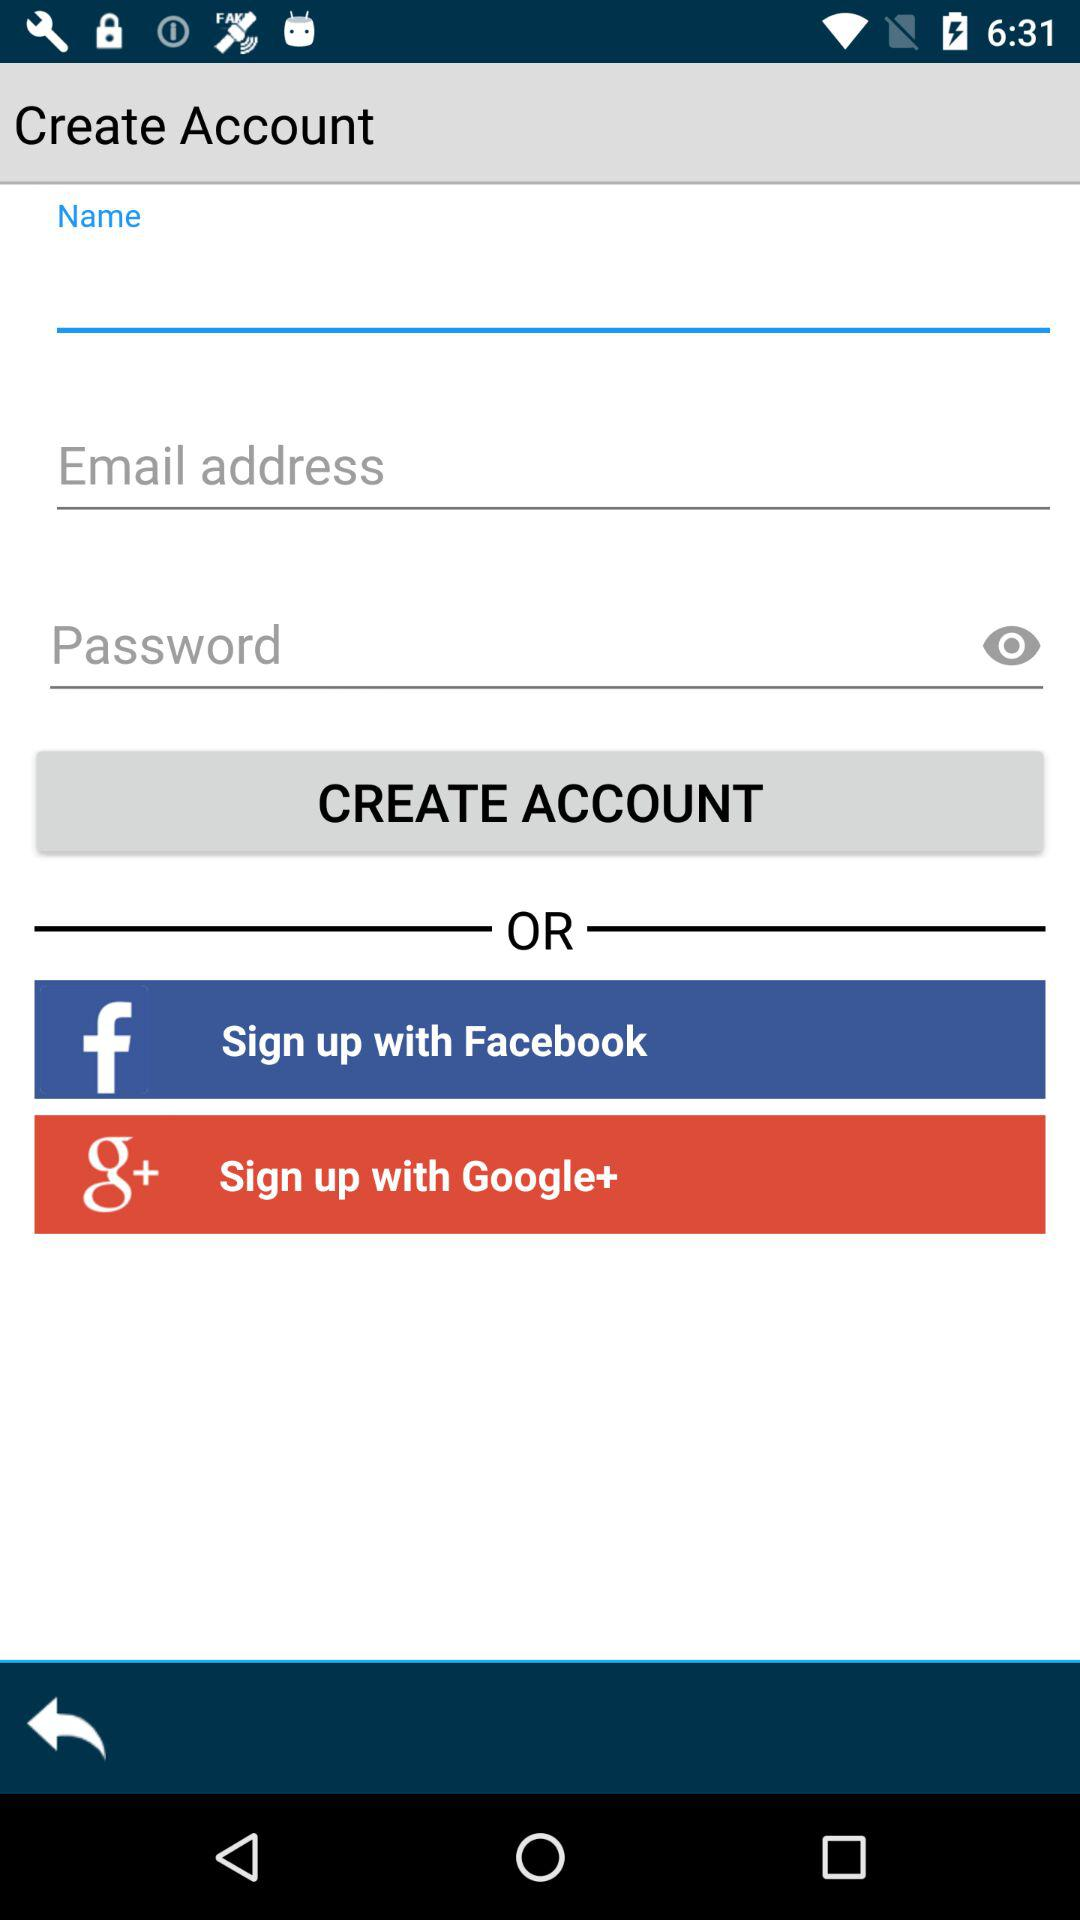What are the different options available for signup? The different options available for signup are "Facebook" and "Google+". 